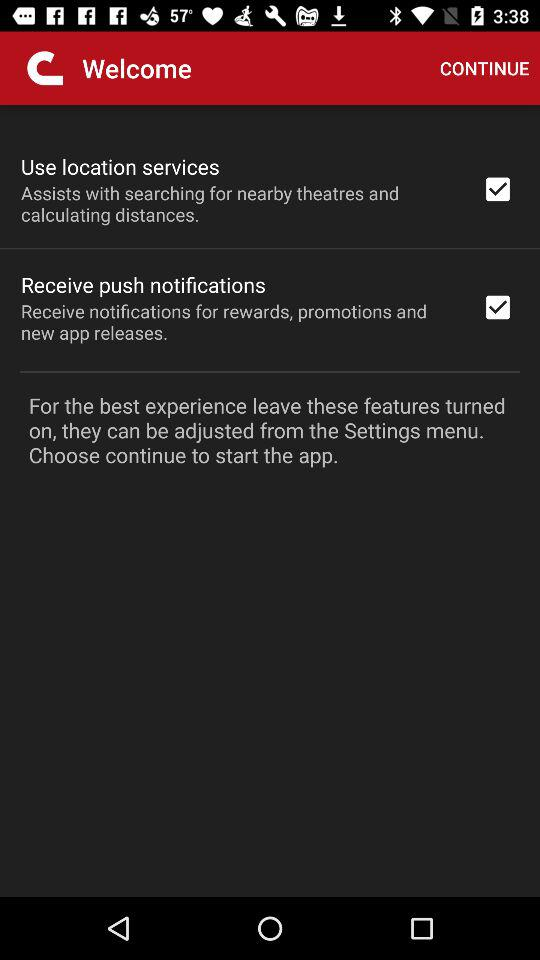What is the status of "Use location services"? The status is "on". 